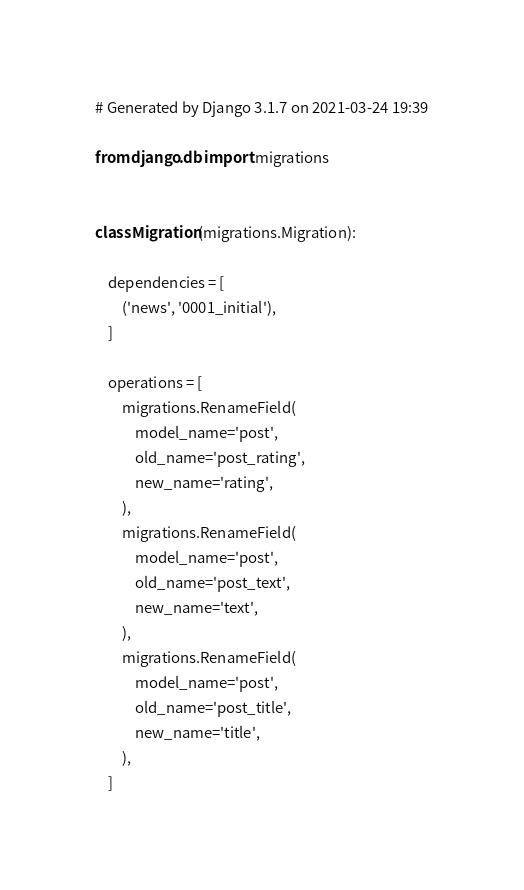Convert code to text. <code><loc_0><loc_0><loc_500><loc_500><_Python_># Generated by Django 3.1.7 on 2021-03-24 19:39

from django.db import migrations


class Migration(migrations.Migration):

    dependencies = [
        ('news', '0001_initial'),
    ]

    operations = [
        migrations.RenameField(
            model_name='post',
            old_name='post_rating',
            new_name='rating',
        ),
        migrations.RenameField(
            model_name='post',
            old_name='post_text',
            new_name='text',
        ),
        migrations.RenameField(
            model_name='post',
            old_name='post_title',
            new_name='title',
        ),
    ]
</code> 